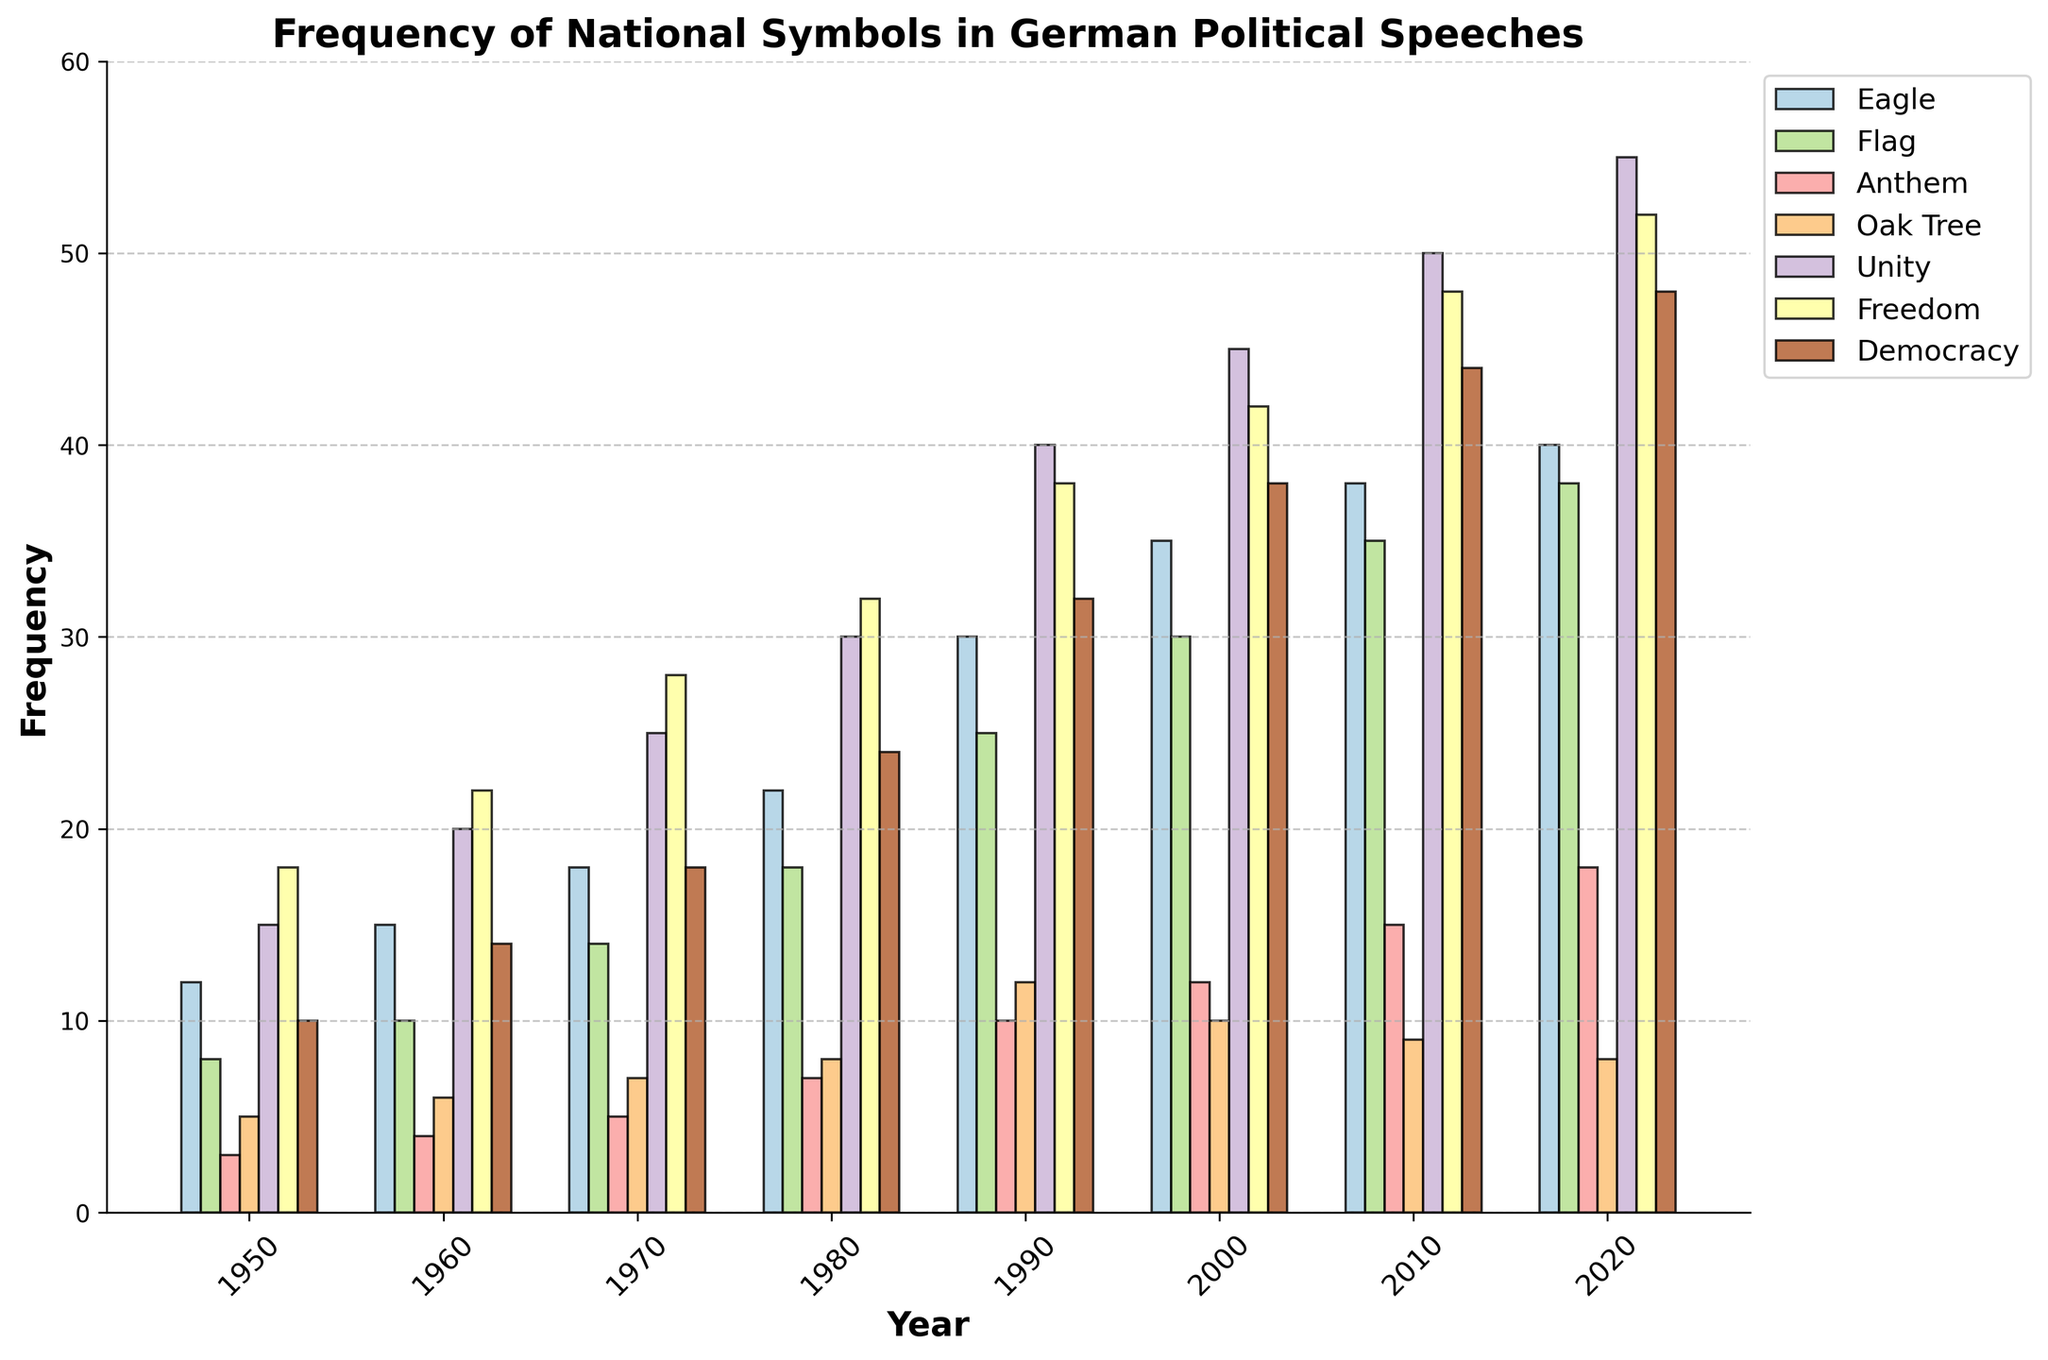What year shows the maximum frequency for the symbol 'Unity'? Observe the height of the bars corresponding to the 'Unity' category. The year with the highest bar represents the maximum frequency. The highest bar for 'Unity' is in the year 2020.
Answer: 2020 Which symbol had the highest increase in frequency between 1950 and 2020? Calculate the difference in frequency for each symbol between 1950 and 2020. 'Eagle': 40 - 12 = 28, 'Flag': 38 - 8 = 30, 'Anthem': 18 - 3 = 15, 'Oak Tree': 8 - 5 = 3, 'Unity': 55 - 15 = 40, 'Freedom': 52 - 18 = 34, 'Democracy': 48 - 10 = 38. The highest increase is for 'Unity'.
Answer: Unity How does the frequency of 'Eagle' in 1980 compare to 'Anthem' in 2000? Look at the height of the bars for 'Eagle' in 1980 and 'Anthem' in 2000. 'Eagle' in 1980 has a frequency of 22, while 'Anthem' in 2000 has a frequency of 12. Thus, 'Eagle' in 1980 has a higher frequency.
Answer: Higher Which symbols' frequencies decreased from 2000 to 2020? Compare the heights of the bars for each symbol between 2000 and 2020. 'Eagle': 35 to 40 (increase), 'Flag': 30 to 38 (increase), 'Anthem': 12 to 18 (increase), 'Oak Tree': 10 to 8 (decrease), 'Unity': 45 to 55 (increase), 'Freedom': 42 to 52 (increase), 'Democracy': 38 to 48 (increase). Only 'Oak Tree' shows a decrease.
Answer: Oak Tree What is the total frequency of the 'Flag' symbol across all years? Sum the frequencies of the 'Flag' symbol for each year: 8 + 10 + 14 + 18 + 25 + 30 + 35 + 38 = 178.
Answer: 178 Which year shows the closest frequencies between 'Freedom' and 'Democracy', and what are those frequencies? Compare the absolute differences in frequencies between 'Freedom' and 'Democracy' for each year: 1950: 18 - 10 = 8, 1960: 22 - 14 = 8, 1970: 28 - 18 = 10, 1980: 32 - 24 = 8, 1990: 38 - 32 = 6, 2000: 42 - 38 = 4, 2010: 48 - 44 = 4, 2020: 52 - 48 = 4. The closest frequencies occur in 2000, 2010, and 2020, with differences of 4. The frequencies are 42 vs. 38 (2000), 48 vs. 44 (2010), and 52 vs. 48 (2020).
Answer: 2000, 2010, 2020; 42 vs. 38, 48 vs. 44, 52 vs. 48 How many times was the symbol 'Democracy' used more frequently than 'Freedom'? Compare the frequencies of 'Democracy' and 'Freedom' for each year: 1950: 10 vs. 18 (less), 1960: 14 vs. 22 (less), 1970: 18 vs. 28 (less), 1980: 24 vs. 32 (less), 1990: 32 vs. 38 (less), 2000: 38 vs. 42 (less), 2010: 44 vs. 48 (less), 2020: 48 vs. 52 (less). 'Democracy' was never used more frequently than 'Freedom'.
Answer: 0 What is the average frequency of 'Oak Tree' over all the years? Calculate the average by summing the frequencies for 'Oak Tree' and dividing by the number of years: (5 + 6 + 7 + 8 + 12 + 10 + 9 + 8) / 8 = 65 / 8 = 8.125.
Answer: 8.125 